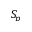<formula> <loc_0><loc_0><loc_500><loc_500>S _ { p }</formula> 